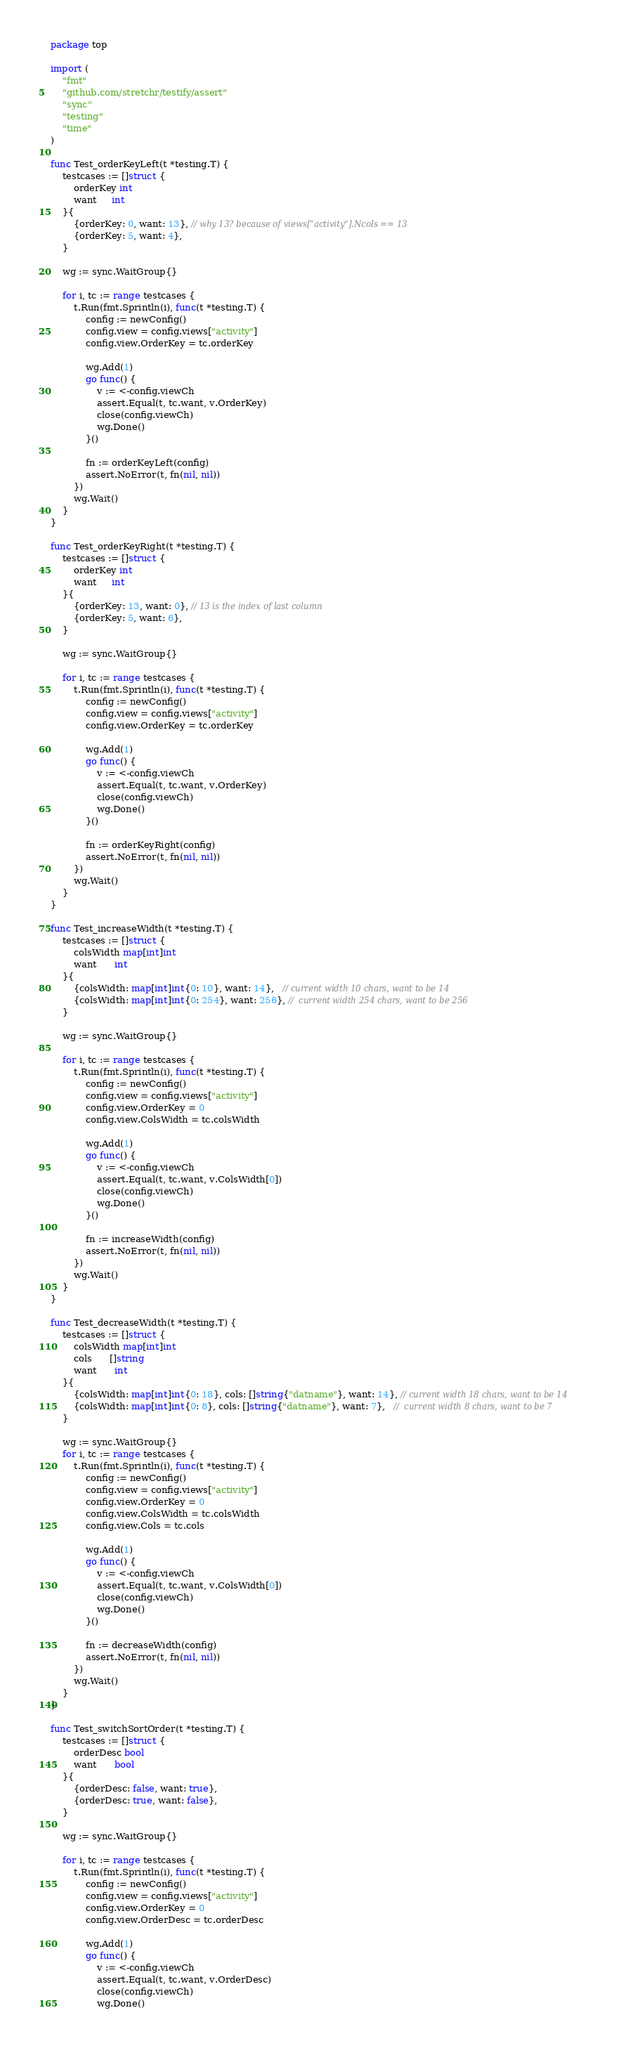Convert code to text. <code><loc_0><loc_0><loc_500><loc_500><_Go_>package top

import (
	"fmt"
	"github.com/stretchr/testify/assert"
	"sync"
	"testing"
	"time"
)

func Test_orderKeyLeft(t *testing.T) {
	testcases := []struct {
		orderKey int
		want     int
	}{
		{orderKey: 0, want: 13}, // why 13? because of views["activity"].Ncols == 13
		{orderKey: 5, want: 4},
	}

	wg := sync.WaitGroup{}

	for i, tc := range testcases {
		t.Run(fmt.Sprintln(i), func(t *testing.T) {
			config := newConfig()
			config.view = config.views["activity"]
			config.view.OrderKey = tc.orderKey

			wg.Add(1)
			go func() {
				v := <-config.viewCh
				assert.Equal(t, tc.want, v.OrderKey)
				close(config.viewCh)
				wg.Done()
			}()

			fn := orderKeyLeft(config)
			assert.NoError(t, fn(nil, nil))
		})
		wg.Wait()
	}
}

func Test_orderKeyRight(t *testing.T) {
	testcases := []struct {
		orderKey int
		want     int
	}{
		{orderKey: 13, want: 0}, // 13 is the index of last column
		{orderKey: 5, want: 6},
	}

	wg := sync.WaitGroup{}

	for i, tc := range testcases {
		t.Run(fmt.Sprintln(i), func(t *testing.T) {
			config := newConfig()
			config.view = config.views["activity"]
			config.view.OrderKey = tc.orderKey

			wg.Add(1)
			go func() {
				v := <-config.viewCh
				assert.Equal(t, tc.want, v.OrderKey)
				close(config.viewCh)
				wg.Done()
			}()

			fn := orderKeyRight(config)
			assert.NoError(t, fn(nil, nil))
		})
		wg.Wait()
	}
}

func Test_increaseWidth(t *testing.T) {
	testcases := []struct {
		colsWidth map[int]int
		want      int
	}{
		{colsWidth: map[int]int{0: 10}, want: 14},   // current width 10 chars, want to be 14
		{colsWidth: map[int]int{0: 254}, want: 256}, //  current width 254 chars, want to be 256
	}

	wg := sync.WaitGroup{}

	for i, tc := range testcases {
		t.Run(fmt.Sprintln(i), func(t *testing.T) {
			config := newConfig()
			config.view = config.views["activity"]
			config.view.OrderKey = 0
			config.view.ColsWidth = tc.colsWidth

			wg.Add(1)
			go func() {
				v := <-config.viewCh
				assert.Equal(t, tc.want, v.ColsWidth[0])
				close(config.viewCh)
				wg.Done()
			}()

			fn := increaseWidth(config)
			assert.NoError(t, fn(nil, nil))
		})
		wg.Wait()
	}
}

func Test_decreaseWidth(t *testing.T) {
	testcases := []struct {
		colsWidth map[int]int
		cols      []string
		want      int
	}{
		{colsWidth: map[int]int{0: 18}, cols: []string{"datname"}, want: 14}, // current width 18 chars, want to be 14
		{colsWidth: map[int]int{0: 8}, cols: []string{"datname"}, want: 7},   //  current width 8 chars, want to be 7
	}

	wg := sync.WaitGroup{}
	for i, tc := range testcases {
		t.Run(fmt.Sprintln(i), func(t *testing.T) {
			config := newConfig()
			config.view = config.views["activity"]
			config.view.OrderKey = 0
			config.view.ColsWidth = tc.colsWidth
			config.view.Cols = tc.cols

			wg.Add(1)
			go func() {
				v := <-config.viewCh
				assert.Equal(t, tc.want, v.ColsWidth[0])
				close(config.viewCh)
				wg.Done()
			}()

			fn := decreaseWidth(config)
			assert.NoError(t, fn(nil, nil))
		})
		wg.Wait()
	}
}

func Test_switchSortOrder(t *testing.T) {
	testcases := []struct {
		orderDesc bool
		want      bool
	}{
		{orderDesc: false, want: true},
		{orderDesc: true, want: false},
	}

	wg := sync.WaitGroup{}

	for i, tc := range testcases {
		t.Run(fmt.Sprintln(i), func(t *testing.T) {
			config := newConfig()
			config.view = config.views["activity"]
			config.view.OrderKey = 0
			config.view.OrderDesc = tc.orderDesc

			wg.Add(1)
			go func() {
				v := <-config.viewCh
				assert.Equal(t, tc.want, v.OrderDesc)
				close(config.viewCh)
				wg.Done()</code> 